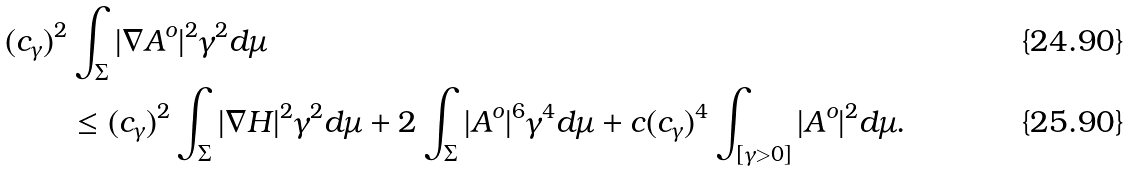<formula> <loc_0><loc_0><loc_500><loc_500>( c _ { \gamma } ) ^ { 2 } & \int _ { \Sigma } | \nabla A ^ { o } | ^ { 2 } \gamma ^ { 2 } d \mu \\ & \leq ( c _ { \gamma } ) ^ { 2 } \int _ { \Sigma } | \nabla H | ^ { 2 } \gamma ^ { 2 } d \mu + 2 \int _ { \Sigma } | A ^ { o } | ^ { 6 } \gamma ^ { 4 } d \mu + c ( c _ { \gamma } ) ^ { 4 } \int _ { [ \gamma > 0 ] } | A ^ { o } | ^ { 2 } d \mu .</formula> 